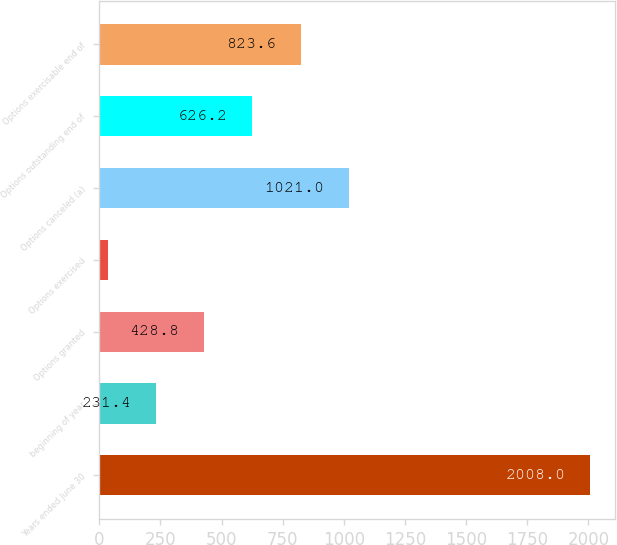<chart> <loc_0><loc_0><loc_500><loc_500><bar_chart><fcel>Years ended June 30<fcel>beginning of year<fcel>Options granted<fcel>Options exercised<fcel>Options canceled (a)<fcel>Options outstanding end of<fcel>Options exercisable end of<nl><fcel>2008<fcel>231.4<fcel>428.8<fcel>34<fcel>1021<fcel>626.2<fcel>823.6<nl></chart> 